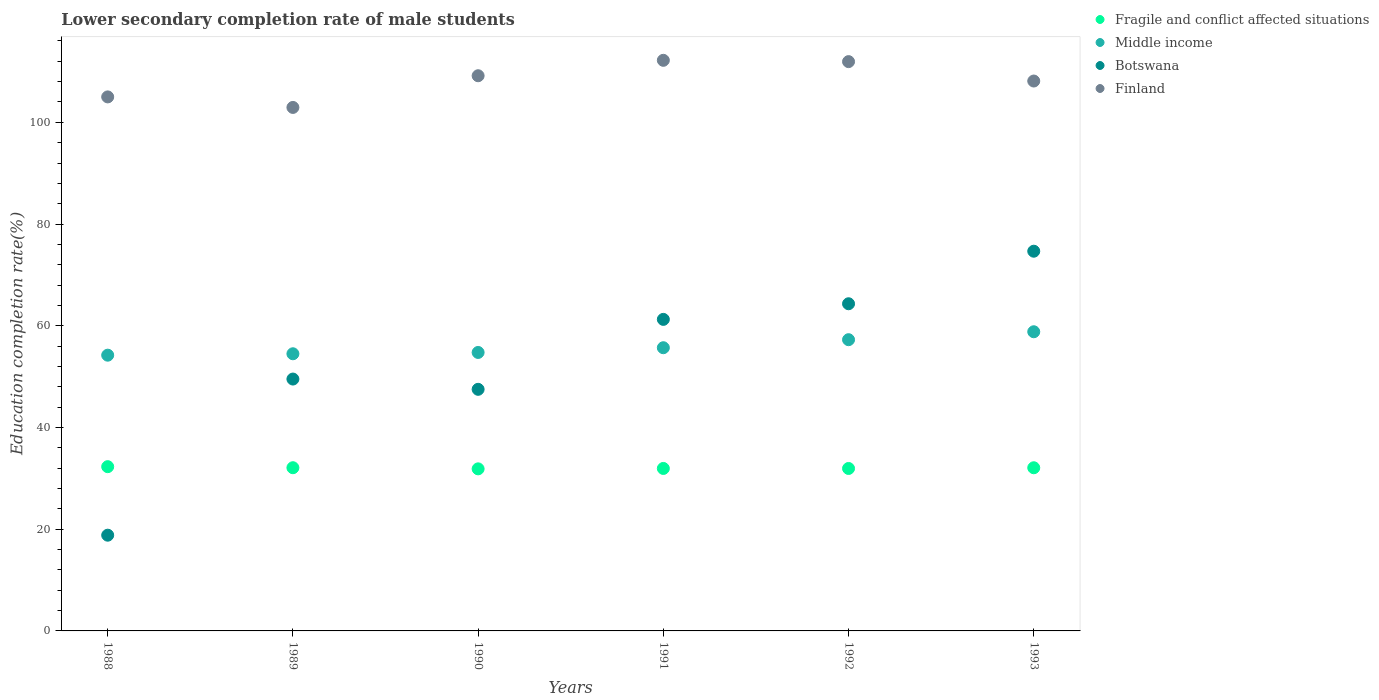How many different coloured dotlines are there?
Offer a very short reply. 4. What is the lower secondary completion rate of male students in Middle income in 1992?
Your answer should be very brief. 57.26. Across all years, what is the maximum lower secondary completion rate of male students in Botswana?
Offer a very short reply. 74.66. Across all years, what is the minimum lower secondary completion rate of male students in Middle income?
Your answer should be very brief. 54.22. In which year was the lower secondary completion rate of male students in Botswana maximum?
Give a very brief answer. 1993. In which year was the lower secondary completion rate of male students in Fragile and conflict affected situations minimum?
Provide a succinct answer. 1990. What is the total lower secondary completion rate of male students in Middle income in the graph?
Provide a short and direct response. 335.22. What is the difference between the lower secondary completion rate of male students in Botswana in 1989 and that in 1991?
Your answer should be compact. -11.73. What is the difference between the lower secondary completion rate of male students in Fragile and conflict affected situations in 1991 and the lower secondary completion rate of male students in Middle income in 1992?
Offer a terse response. -25.31. What is the average lower secondary completion rate of male students in Middle income per year?
Provide a short and direct response. 55.87. In the year 1989, what is the difference between the lower secondary completion rate of male students in Botswana and lower secondary completion rate of male students in Finland?
Make the answer very short. -53.4. What is the ratio of the lower secondary completion rate of male students in Fragile and conflict affected situations in 1991 to that in 1992?
Your answer should be very brief. 1. Is the lower secondary completion rate of male students in Finland in 1991 less than that in 1993?
Ensure brevity in your answer.  No. What is the difference between the highest and the second highest lower secondary completion rate of male students in Middle income?
Keep it short and to the point. 1.56. What is the difference between the highest and the lowest lower secondary completion rate of male students in Botswana?
Your answer should be compact. 55.83. In how many years, is the lower secondary completion rate of male students in Botswana greater than the average lower secondary completion rate of male students in Botswana taken over all years?
Ensure brevity in your answer.  3. Is the sum of the lower secondary completion rate of male students in Finland in 1988 and 1989 greater than the maximum lower secondary completion rate of male students in Fragile and conflict affected situations across all years?
Your answer should be very brief. Yes. Is it the case that in every year, the sum of the lower secondary completion rate of male students in Botswana and lower secondary completion rate of male students in Fragile and conflict affected situations  is greater than the sum of lower secondary completion rate of male students in Finland and lower secondary completion rate of male students in Middle income?
Provide a short and direct response. No. Is it the case that in every year, the sum of the lower secondary completion rate of male students in Fragile and conflict affected situations and lower secondary completion rate of male students in Finland  is greater than the lower secondary completion rate of male students in Botswana?
Offer a terse response. Yes. Does the lower secondary completion rate of male students in Botswana monotonically increase over the years?
Keep it short and to the point. No. Is the lower secondary completion rate of male students in Finland strictly less than the lower secondary completion rate of male students in Fragile and conflict affected situations over the years?
Provide a short and direct response. No. What is the difference between two consecutive major ticks on the Y-axis?
Your answer should be very brief. 20. Are the values on the major ticks of Y-axis written in scientific E-notation?
Your response must be concise. No. Does the graph contain grids?
Keep it short and to the point. No. What is the title of the graph?
Give a very brief answer. Lower secondary completion rate of male students. Does "Uzbekistan" appear as one of the legend labels in the graph?
Make the answer very short. No. What is the label or title of the Y-axis?
Offer a terse response. Education completion rate(%). What is the Education completion rate(%) in Fragile and conflict affected situations in 1988?
Your answer should be compact. 32.29. What is the Education completion rate(%) in Middle income in 1988?
Offer a very short reply. 54.22. What is the Education completion rate(%) in Botswana in 1988?
Your answer should be compact. 18.82. What is the Education completion rate(%) of Finland in 1988?
Your answer should be compact. 105. What is the Education completion rate(%) of Fragile and conflict affected situations in 1989?
Your answer should be compact. 32.09. What is the Education completion rate(%) in Middle income in 1989?
Keep it short and to the point. 54.49. What is the Education completion rate(%) in Botswana in 1989?
Your response must be concise. 49.52. What is the Education completion rate(%) of Finland in 1989?
Ensure brevity in your answer.  102.93. What is the Education completion rate(%) of Fragile and conflict affected situations in 1990?
Your response must be concise. 31.86. What is the Education completion rate(%) of Middle income in 1990?
Ensure brevity in your answer.  54.75. What is the Education completion rate(%) of Botswana in 1990?
Offer a terse response. 47.5. What is the Education completion rate(%) in Finland in 1990?
Your answer should be very brief. 109.16. What is the Education completion rate(%) in Fragile and conflict affected situations in 1991?
Your answer should be very brief. 31.94. What is the Education completion rate(%) in Middle income in 1991?
Your response must be concise. 55.68. What is the Education completion rate(%) in Botswana in 1991?
Provide a short and direct response. 61.25. What is the Education completion rate(%) in Finland in 1991?
Your answer should be compact. 112.19. What is the Education completion rate(%) in Fragile and conflict affected situations in 1992?
Give a very brief answer. 31.94. What is the Education completion rate(%) of Middle income in 1992?
Keep it short and to the point. 57.26. What is the Education completion rate(%) in Botswana in 1992?
Your response must be concise. 64.33. What is the Education completion rate(%) in Finland in 1992?
Keep it short and to the point. 111.93. What is the Education completion rate(%) in Fragile and conflict affected situations in 1993?
Your answer should be very brief. 32.08. What is the Education completion rate(%) of Middle income in 1993?
Give a very brief answer. 58.82. What is the Education completion rate(%) of Botswana in 1993?
Provide a succinct answer. 74.66. What is the Education completion rate(%) in Finland in 1993?
Offer a very short reply. 108.12. Across all years, what is the maximum Education completion rate(%) in Fragile and conflict affected situations?
Ensure brevity in your answer.  32.29. Across all years, what is the maximum Education completion rate(%) in Middle income?
Offer a very short reply. 58.82. Across all years, what is the maximum Education completion rate(%) in Botswana?
Ensure brevity in your answer.  74.66. Across all years, what is the maximum Education completion rate(%) in Finland?
Your answer should be very brief. 112.19. Across all years, what is the minimum Education completion rate(%) in Fragile and conflict affected situations?
Provide a short and direct response. 31.86. Across all years, what is the minimum Education completion rate(%) of Middle income?
Offer a very short reply. 54.22. Across all years, what is the minimum Education completion rate(%) of Botswana?
Provide a short and direct response. 18.82. Across all years, what is the minimum Education completion rate(%) in Finland?
Provide a succinct answer. 102.93. What is the total Education completion rate(%) of Fragile and conflict affected situations in the graph?
Offer a very short reply. 192.21. What is the total Education completion rate(%) of Middle income in the graph?
Provide a short and direct response. 335.22. What is the total Education completion rate(%) of Botswana in the graph?
Offer a very short reply. 316.08. What is the total Education completion rate(%) in Finland in the graph?
Your answer should be very brief. 649.32. What is the difference between the Education completion rate(%) in Fragile and conflict affected situations in 1988 and that in 1989?
Give a very brief answer. 0.21. What is the difference between the Education completion rate(%) in Middle income in 1988 and that in 1989?
Your answer should be very brief. -0.28. What is the difference between the Education completion rate(%) in Botswana in 1988 and that in 1989?
Your response must be concise. -30.7. What is the difference between the Education completion rate(%) of Finland in 1988 and that in 1989?
Provide a succinct answer. 2.07. What is the difference between the Education completion rate(%) of Fragile and conflict affected situations in 1988 and that in 1990?
Offer a terse response. 0.43. What is the difference between the Education completion rate(%) in Middle income in 1988 and that in 1990?
Offer a very short reply. -0.54. What is the difference between the Education completion rate(%) in Botswana in 1988 and that in 1990?
Provide a short and direct response. -28.68. What is the difference between the Education completion rate(%) in Finland in 1988 and that in 1990?
Keep it short and to the point. -4.16. What is the difference between the Education completion rate(%) in Fragile and conflict affected situations in 1988 and that in 1991?
Give a very brief answer. 0.35. What is the difference between the Education completion rate(%) in Middle income in 1988 and that in 1991?
Ensure brevity in your answer.  -1.47. What is the difference between the Education completion rate(%) in Botswana in 1988 and that in 1991?
Provide a short and direct response. -42.43. What is the difference between the Education completion rate(%) in Finland in 1988 and that in 1991?
Make the answer very short. -7.19. What is the difference between the Education completion rate(%) of Fragile and conflict affected situations in 1988 and that in 1992?
Provide a short and direct response. 0.35. What is the difference between the Education completion rate(%) in Middle income in 1988 and that in 1992?
Make the answer very short. -3.04. What is the difference between the Education completion rate(%) in Botswana in 1988 and that in 1992?
Your response must be concise. -45.5. What is the difference between the Education completion rate(%) of Finland in 1988 and that in 1992?
Provide a succinct answer. -6.94. What is the difference between the Education completion rate(%) in Fragile and conflict affected situations in 1988 and that in 1993?
Keep it short and to the point. 0.21. What is the difference between the Education completion rate(%) of Middle income in 1988 and that in 1993?
Provide a succinct answer. -4.6. What is the difference between the Education completion rate(%) in Botswana in 1988 and that in 1993?
Give a very brief answer. -55.83. What is the difference between the Education completion rate(%) in Finland in 1988 and that in 1993?
Provide a short and direct response. -3.12. What is the difference between the Education completion rate(%) in Fragile and conflict affected situations in 1989 and that in 1990?
Make the answer very short. 0.22. What is the difference between the Education completion rate(%) in Middle income in 1989 and that in 1990?
Make the answer very short. -0.26. What is the difference between the Education completion rate(%) in Botswana in 1989 and that in 1990?
Keep it short and to the point. 2.02. What is the difference between the Education completion rate(%) in Finland in 1989 and that in 1990?
Provide a short and direct response. -6.23. What is the difference between the Education completion rate(%) of Fragile and conflict affected situations in 1989 and that in 1991?
Provide a short and direct response. 0.14. What is the difference between the Education completion rate(%) in Middle income in 1989 and that in 1991?
Offer a very short reply. -1.19. What is the difference between the Education completion rate(%) in Botswana in 1989 and that in 1991?
Provide a succinct answer. -11.73. What is the difference between the Education completion rate(%) in Finland in 1989 and that in 1991?
Give a very brief answer. -9.26. What is the difference between the Education completion rate(%) in Fragile and conflict affected situations in 1989 and that in 1992?
Make the answer very short. 0.15. What is the difference between the Education completion rate(%) of Middle income in 1989 and that in 1992?
Make the answer very short. -2.77. What is the difference between the Education completion rate(%) in Botswana in 1989 and that in 1992?
Provide a short and direct response. -14.8. What is the difference between the Education completion rate(%) in Finland in 1989 and that in 1992?
Offer a very short reply. -9.01. What is the difference between the Education completion rate(%) of Fragile and conflict affected situations in 1989 and that in 1993?
Ensure brevity in your answer.  0.01. What is the difference between the Education completion rate(%) in Middle income in 1989 and that in 1993?
Provide a succinct answer. -4.33. What is the difference between the Education completion rate(%) of Botswana in 1989 and that in 1993?
Give a very brief answer. -25.14. What is the difference between the Education completion rate(%) in Finland in 1989 and that in 1993?
Offer a terse response. -5.19. What is the difference between the Education completion rate(%) in Fragile and conflict affected situations in 1990 and that in 1991?
Keep it short and to the point. -0.08. What is the difference between the Education completion rate(%) in Middle income in 1990 and that in 1991?
Your answer should be compact. -0.93. What is the difference between the Education completion rate(%) in Botswana in 1990 and that in 1991?
Offer a very short reply. -13.75. What is the difference between the Education completion rate(%) of Finland in 1990 and that in 1991?
Make the answer very short. -3.03. What is the difference between the Education completion rate(%) in Fragile and conflict affected situations in 1990 and that in 1992?
Make the answer very short. -0.08. What is the difference between the Education completion rate(%) in Middle income in 1990 and that in 1992?
Provide a short and direct response. -2.51. What is the difference between the Education completion rate(%) in Botswana in 1990 and that in 1992?
Offer a very short reply. -16.82. What is the difference between the Education completion rate(%) in Finland in 1990 and that in 1992?
Make the answer very short. -2.77. What is the difference between the Education completion rate(%) of Fragile and conflict affected situations in 1990 and that in 1993?
Your answer should be compact. -0.22. What is the difference between the Education completion rate(%) of Middle income in 1990 and that in 1993?
Your answer should be compact. -4.07. What is the difference between the Education completion rate(%) of Botswana in 1990 and that in 1993?
Your response must be concise. -27.15. What is the difference between the Education completion rate(%) of Finland in 1990 and that in 1993?
Your answer should be very brief. 1.04. What is the difference between the Education completion rate(%) of Fragile and conflict affected situations in 1991 and that in 1992?
Keep it short and to the point. 0. What is the difference between the Education completion rate(%) of Middle income in 1991 and that in 1992?
Give a very brief answer. -1.58. What is the difference between the Education completion rate(%) of Botswana in 1991 and that in 1992?
Offer a very short reply. -3.07. What is the difference between the Education completion rate(%) in Finland in 1991 and that in 1992?
Offer a very short reply. 0.26. What is the difference between the Education completion rate(%) of Fragile and conflict affected situations in 1991 and that in 1993?
Provide a succinct answer. -0.14. What is the difference between the Education completion rate(%) in Middle income in 1991 and that in 1993?
Ensure brevity in your answer.  -3.14. What is the difference between the Education completion rate(%) of Botswana in 1991 and that in 1993?
Give a very brief answer. -13.4. What is the difference between the Education completion rate(%) in Finland in 1991 and that in 1993?
Keep it short and to the point. 4.07. What is the difference between the Education completion rate(%) in Fragile and conflict affected situations in 1992 and that in 1993?
Give a very brief answer. -0.14. What is the difference between the Education completion rate(%) in Middle income in 1992 and that in 1993?
Provide a succinct answer. -1.56. What is the difference between the Education completion rate(%) of Botswana in 1992 and that in 1993?
Make the answer very short. -10.33. What is the difference between the Education completion rate(%) in Finland in 1992 and that in 1993?
Make the answer very short. 3.81. What is the difference between the Education completion rate(%) of Fragile and conflict affected situations in 1988 and the Education completion rate(%) of Middle income in 1989?
Your answer should be compact. -22.2. What is the difference between the Education completion rate(%) of Fragile and conflict affected situations in 1988 and the Education completion rate(%) of Botswana in 1989?
Your response must be concise. -17.23. What is the difference between the Education completion rate(%) in Fragile and conflict affected situations in 1988 and the Education completion rate(%) in Finland in 1989?
Keep it short and to the point. -70.63. What is the difference between the Education completion rate(%) in Middle income in 1988 and the Education completion rate(%) in Botswana in 1989?
Keep it short and to the point. 4.69. What is the difference between the Education completion rate(%) in Middle income in 1988 and the Education completion rate(%) in Finland in 1989?
Offer a terse response. -48.71. What is the difference between the Education completion rate(%) in Botswana in 1988 and the Education completion rate(%) in Finland in 1989?
Offer a terse response. -84.1. What is the difference between the Education completion rate(%) of Fragile and conflict affected situations in 1988 and the Education completion rate(%) of Middle income in 1990?
Give a very brief answer. -22.46. What is the difference between the Education completion rate(%) in Fragile and conflict affected situations in 1988 and the Education completion rate(%) in Botswana in 1990?
Provide a short and direct response. -15.21. What is the difference between the Education completion rate(%) of Fragile and conflict affected situations in 1988 and the Education completion rate(%) of Finland in 1990?
Give a very brief answer. -76.86. What is the difference between the Education completion rate(%) of Middle income in 1988 and the Education completion rate(%) of Botswana in 1990?
Your answer should be compact. 6.71. What is the difference between the Education completion rate(%) in Middle income in 1988 and the Education completion rate(%) in Finland in 1990?
Provide a succinct answer. -54.94. What is the difference between the Education completion rate(%) of Botswana in 1988 and the Education completion rate(%) of Finland in 1990?
Offer a very short reply. -90.33. What is the difference between the Education completion rate(%) in Fragile and conflict affected situations in 1988 and the Education completion rate(%) in Middle income in 1991?
Make the answer very short. -23.39. What is the difference between the Education completion rate(%) in Fragile and conflict affected situations in 1988 and the Education completion rate(%) in Botswana in 1991?
Make the answer very short. -28.96. What is the difference between the Education completion rate(%) in Fragile and conflict affected situations in 1988 and the Education completion rate(%) in Finland in 1991?
Offer a terse response. -79.9. What is the difference between the Education completion rate(%) in Middle income in 1988 and the Education completion rate(%) in Botswana in 1991?
Provide a succinct answer. -7.04. What is the difference between the Education completion rate(%) in Middle income in 1988 and the Education completion rate(%) in Finland in 1991?
Your answer should be compact. -57.97. What is the difference between the Education completion rate(%) in Botswana in 1988 and the Education completion rate(%) in Finland in 1991?
Provide a succinct answer. -93.37. What is the difference between the Education completion rate(%) in Fragile and conflict affected situations in 1988 and the Education completion rate(%) in Middle income in 1992?
Offer a terse response. -24.96. What is the difference between the Education completion rate(%) of Fragile and conflict affected situations in 1988 and the Education completion rate(%) of Botswana in 1992?
Offer a very short reply. -32.03. What is the difference between the Education completion rate(%) of Fragile and conflict affected situations in 1988 and the Education completion rate(%) of Finland in 1992?
Keep it short and to the point. -79.64. What is the difference between the Education completion rate(%) of Middle income in 1988 and the Education completion rate(%) of Botswana in 1992?
Your response must be concise. -10.11. What is the difference between the Education completion rate(%) in Middle income in 1988 and the Education completion rate(%) in Finland in 1992?
Your answer should be very brief. -57.72. What is the difference between the Education completion rate(%) of Botswana in 1988 and the Education completion rate(%) of Finland in 1992?
Keep it short and to the point. -93.11. What is the difference between the Education completion rate(%) of Fragile and conflict affected situations in 1988 and the Education completion rate(%) of Middle income in 1993?
Keep it short and to the point. -26.53. What is the difference between the Education completion rate(%) in Fragile and conflict affected situations in 1988 and the Education completion rate(%) in Botswana in 1993?
Provide a short and direct response. -42.36. What is the difference between the Education completion rate(%) of Fragile and conflict affected situations in 1988 and the Education completion rate(%) of Finland in 1993?
Offer a very short reply. -75.82. What is the difference between the Education completion rate(%) in Middle income in 1988 and the Education completion rate(%) in Botswana in 1993?
Your response must be concise. -20.44. What is the difference between the Education completion rate(%) in Middle income in 1988 and the Education completion rate(%) in Finland in 1993?
Give a very brief answer. -53.9. What is the difference between the Education completion rate(%) of Botswana in 1988 and the Education completion rate(%) of Finland in 1993?
Your answer should be very brief. -89.29. What is the difference between the Education completion rate(%) in Fragile and conflict affected situations in 1989 and the Education completion rate(%) in Middle income in 1990?
Your response must be concise. -22.66. What is the difference between the Education completion rate(%) of Fragile and conflict affected situations in 1989 and the Education completion rate(%) of Botswana in 1990?
Your answer should be very brief. -15.41. What is the difference between the Education completion rate(%) of Fragile and conflict affected situations in 1989 and the Education completion rate(%) of Finland in 1990?
Offer a very short reply. -77.07. What is the difference between the Education completion rate(%) in Middle income in 1989 and the Education completion rate(%) in Botswana in 1990?
Provide a short and direct response. 6.99. What is the difference between the Education completion rate(%) in Middle income in 1989 and the Education completion rate(%) in Finland in 1990?
Provide a short and direct response. -54.66. What is the difference between the Education completion rate(%) of Botswana in 1989 and the Education completion rate(%) of Finland in 1990?
Your answer should be compact. -59.64. What is the difference between the Education completion rate(%) in Fragile and conflict affected situations in 1989 and the Education completion rate(%) in Middle income in 1991?
Your answer should be compact. -23.59. What is the difference between the Education completion rate(%) of Fragile and conflict affected situations in 1989 and the Education completion rate(%) of Botswana in 1991?
Make the answer very short. -29.16. What is the difference between the Education completion rate(%) in Fragile and conflict affected situations in 1989 and the Education completion rate(%) in Finland in 1991?
Give a very brief answer. -80.1. What is the difference between the Education completion rate(%) in Middle income in 1989 and the Education completion rate(%) in Botswana in 1991?
Ensure brevity in your answer.  -6.76. What is the difference between the Education completion rate(%) of Middle income in 1989 and the Education completion rate(%) of Finland in 1991?
Your answer should be compact. -57.7. What is the difference between the Education completion rate(%) of Botswana in 1989 and the Education completion rate(%) of Finland in 1991?
Your answer should be very brief. -62.67. What is the difference between the Education completion rate(%) in Fragile and conflict affected situations in 1989 and the Education completion rate(%) in Middle income in 1992?
Ensure brevity in your answer.  -25.17. What is the difference between the Education completion rate(%) in Fragile and conflict affected situations in 1989 and the Education completion rate(%) in Botswana in 1992?
Make the answer very short. -32.24. What is the difference between the Education completion rate(%) of Fragile and conflict affected situations in 1989 and the Education completion rate(%) of Finland in 1992?
Make the answer very short. -79.84. What is the difference between the Education completion rate(%) in Middle income in 1989 and the Education completion rate(%) in Botswana in 1992?
Your response must be concise. -9.83. What is the difference between the Education completion rate(%) in Middle income in 1989 and the Education completion rate(%) in Finland in 1992?
Make the answer very short. -57.44. What is the difference between the Education completion rate(%) in Botswana in 1989 and the Education completion rate(%) in Finland in 1992?
Make the answer very short. -62.41. What is the difference between the Education completion rate(%) of Fragile and conflict affected situations in 1989 and the Education completion rate(%) of Middle income in 1993?
Provide a short and direct response. -26.73. What is the difference between the Education completion rate(%) of Fragile and conflict affected situations in 1989 and the Education completion rate(%) of Botswana in 1993?
Your answer should be compact. -42.57. What is the difference between the Education completion rate(%) of Fragile and conflict affected situations in 1989 and the Education completion rate(%) of Finland in 1993?
Your answer should be compact. -76.03. What is the difference between the Education completion rate(%) of Middle income in 1989 and the Education completion rate(%) of Botswana in 1993?
Ensure brevity in your answer.  -20.16. What is the difference between the Education completion rate(%) of Middle income in 1989 and the Education completion rate(%) of Finland in 1993?
Provide a short and direct response. -53.62. What is the difference between the Education completion rate(%) in Botswana in 1989 and the Education completion rate(%) in Finland in 1993?
Your response must be concise. -58.6. What is the difference between the Education completion rate(%) of Fragile and conflict affected situations in 1990 and the Education completion rate(%) of Middle income in 1991?
Your answer should be compact. -23.82. What is the difference between the Education completion rate(%) of Fragile and conflict affected situations in 1990 and the Education completion rate(%) of Botswana in 1991?
Your answer should be very brief. -29.39. What is the difference between the Education completion rate(%) of Fragile and conflict affected situations in 1990 and the Education completion rate(%) of Finland in 1991?
Give a very brief answer. -80.32. What is the difference between the Education completion rate(%) of Middle income in 1990 and the Education completion rate(%) of Botswana in 1991?
Your answer should be very brief. -6.5. What is the difference between the Education completion rate(%) in Middle income in 1990 and the Education completion rate(%) in Finland in 1991?
Provide a short and direct response. -57.44. What is the difference between the Education completion rate(%) of Botswana in 1990 and the Education completion rate(%) of Finland in 1991?
Ensure brevity in your answer.  -64.69. What is the difference between the Education completion rate(%) of Fragile and conflict affected situations in 1990 and the Education completion rate(%) of Middle income in 1992?
Your response must be concise. -25.39. What is the difference between the Education completion rate(%) of Fragile and conflict affected situations in 1990 and the Education completion rate(%) of Botswana in 1992?
Your response must be concise. -32.46. What is the difference between the Education completion rate(%) of Fragile and conflict affected situations in 1990 and the Education completion rate(%) of Finland in 1992?
Make the answer very short. -80.07. What is the difference between the Education completion rate(%) of Middle income in 1990 and the Education completion rate(%) of Botswana in 1992?
Your response must be concise. -9.58. What is the difference between the Education completion rate(%) in Middle income in 1990 and the Education completion rate(%) in Finland in 1992?
Make the answer very short. -57.18. What is the difference between the Education completion rate(%) in Botswana in 1990 and the Education completion rate(%) in Finland in 1992?
Keep it short and to the point. -64.43. What is the difference between the Education completion rate(%) in Fragile and conflict affected situations in 1990 and the Education completion rate(%) in Middle income in 1993?
Offer a terse response. -26.96. What is the difference between the Education completion rate(%) of Fragile and conflict affected situations in 1990 and the Education completion rate(%) of Botswana in 1993?
Offer a terse response. -42.79. What is the difference between the Education completion rate(%) in Fragile and conflict affected situations in 1990 and the Education completion rate(%) in Finland in 1993?
Ensure brevity in your answer.  -76.25. What is the difference between the Education completion rate(%) in Middle income in 1990 and the Education completion rate(%) in Botswana in 1993?
Keep it short and to the point. -19.91. What is the difference between the Education completion rate(%) in Middle income in 1990 and the Education completion rate(%) in Finland in 1993?
Provide a short and direct response. -53.37. What is the difference between the Education completion rate(%) of Botswana in 1990 and the Education completion rate(%) of Finland in 1993?
Provide a succinct answer. -60.62. What is the difference between the Education completion rate(%) of Fragile and conflict affected situations in 1991 and the Education completion rate(%) of Middle income in 1992?
Offer a very short reply. -25.31. What is the difference between the Education completion rate(%) in Fragile and conflict affected situations in 1991 and the Education completion rate(%) in Botswana in 1992?
Provide a short and direct response. -32.38. What is the difference between the Education completion rate(%) of Fragile and conflict affected situations in 1991 and the Education completion rate(%) of Finland in 1992?
Give a very brief answer. -79.99. What is the difference between the Education completion rate(%) of Middle income in 1991 and the Education completion rate(%) of Botswana in 1992?
Your answer should be compact. -8.64. What is the difference between the Education completion rate(%) of Middle income in 1991 and the Education completion rate(%) of Finland in 1992?
Keep it short and to the point. -56.25. What is the difference between the Education completion rate(%) of Botswana in 1991 and the Education completion rate(%) of Finland in 1992?
Provide a short and direct response. -50.68. What is the difference between the Education completion rate(%) in Fragile and conflict affected situations in 1991 and the Education completion rate(%) in Middle income in 1993?
Make the answer very short. -26.88. What is the difference between the Education completion rate(%) in Fragile and conflict affected situations in 1991 and the Education completion rate(%) in Botswana in 1993?
Offer a very short reply. -42.71. What is the difference between the Education completion rate(%) in Fragile and conflict affected situations in 1991 and the Education completion rate(%) in Finland in 1993?
Your answer should be compact. -76.17. What is the difference between the Education completion rate(%) of Middle income in 1991 and the Education completion rate(%) of Botswana in 1993?
Your response must be concise. -18.97. What is the difference between the Education completion rate(%) in Middle income in 1991 and the Education completion rate(%) in Finland in 1993?
Your response must be concise. -52.44. What is the difference between the Education completion rate(%) in Botswana in 1991 and the Education completion rate(%) in Finland in 1993?
Your answer should be compact. -46.86. What is the difference between the Education completion rate(%) of Fragile and conflict affected situations in 1992 and the Education completion rate(%) of Middle income in 1993?
Make the answer very short. -26.88. What is the difference between the Education completion rate(%) of Fragile and conflict affected situations in 1992 and the Education completion rate(%) of Botswana in 1993?
Provide a succinct answer. -42.72. What is the difference between the Education completion rate(%) in Fragile and conflict affected situations in 1992 and the Education completion rate(%) in Finland in 1993?
Offer a very short reply. -76.18. What is the difference between the Education completion rate(%) in Middle income in 1992 and the Education completion rate(%) in Botswana in 1993?
Your answer should be compact. -17.4. What is the difference between the Education completion rate(%) of Middle income in 1992 and the Education completion rate(%) of Finland in 1993?
Your response must be concise. -50.86. What is the difference between the Education completion rate(%) of Botswana in 1992 and the Education completion rate(%) of Finland in 1993?
Your answer should be very brief. -43.79. What is the average Education completion rate(%) in Fragile and conflict affected situations per year?
Provide a short and direct response. 32.04. What is the average Education completion rate(%) of Middle income per year?
Your answer should be compact. 55.87. What is the average Education completion rate(%) in Botswana per year?
Offer a very short reply. 52.68. What is the average Education completion rate(%) of Finland per year?
Your answer should be compact. 108.22. In the year 1988, what is the difference between the Education completion rate(%) in Fragile and conflict affected situations and Education completion rate(%) in Middle income?
Give a very brief answer. -21.92. In the year 1988, what is the difference between the Education completion rate(%) in Fragile and conflict affected situations and Education completion rate(%) in Botswana?
Your answer should be very brief. 13.47. In the year 1988, what is the difference between the Education completion rate(%) of Fragile and conflict affected situations and Education completion rate(%) of Finland?
Keep it short and to the point. -72.7. In the year 1988, what is the difference between the Education completion rate(%) in Middle income and Education completion rate(%) in Botswana?
Your response must be concise. 35.39. In the year 1988, what is the difference between the Education completion rate(%) in Middle income and Education completion rate(%) in Finland?
Give a very brief answer. -50.78. In the year 1988, what is the difference between the Education completion rate(%) in Botswana and Education completion rate(%) in Finland?
Your response must be concise. -86.17. In the year 1989, what is the difference between the Education completion rate(%) in Fragile and conflict affected situations and Education completion rate(%) in Middle income?
Ensure brevity in your answer.  -22.4. In the year 1989, what is the difference between the Education completion rate(%) in Fragile and conflict affected situations and Education completion rate(%) in Botswana?
Your answer should be very brief. -17.43. In the year 1989, what is the difference between the Education completion rate(%) in Fragile and conflict affected situations and Education completion rate(%) in Finland?
Give a very brief answer. -70.84. In the year 1989, what is the difference between the Education completion rate(%) of Middle income and Education completion rate(%) of Botswana?
Provide a short and direct response. 4.97. In the year 1989, what is the difference between the Education completion rate(%) of Middle income and Education completion rate(%) of Finland?
Offer a terse response. -48.43. In the year 1989, what is the difference between the Education completion rate(%) in Botswana and Education completion rate(%) in Finland?
Ensure brevity in your answer.  -53.4. In the year 1990, what is the difference between the Education completion rate(%) of Fragile and conflict affected situations and Education completion rate(%) of Middle income?
Your answer should be compact. -22.89. In the year 1990, what is the difference between the Education completion rate(%) in Fragile and conflict affected situations and Education completion rate(%) in Botswana?
Your answer should be compact. -15.64. In the year 1990, what is the difference between the Education completion rate(%) in Fragile and conflict affected situations and Education completion rate(%) in Finland?
Provide a short and direct response. -77.29. In the year 1990, what is the difference between the Education completion rate(%) in Middle income and Education completion rate(%) in Botswana?
Provide a short and direct response. 7.25. In the year 1990, what is the difference between the Education completion rate(%) of Middle income and Education completion rate(%) of Finland?
Ensure brevity in your answer.  -54.41. In the year 1990, what is the difference between the Education completion rate(%) in Botswana and Education completion rate(%) in Finland?
Provide a succinct answer. -61.66. In the year 1991, what is the difference between the Education completion rate(%) of Fragile and conflict affected situations and Education completion rate(%) of Middle income?
Ensure brevity in your answer.  -23.74. In the year 1991, what is the difference between the Education completion rate(%) of Fragile and conflict affected situations and Education completion rate(%) of Botswana?
Keep it short and to the point. -29.31. In the year 1991, what is the difference between the Education completion rate(%) of Fragile and conflict affected situations and Education completion rate(%) of Finland?
Your answer should be compact. -80.24. In the year 1991, what is the difference between the Education completion rate(%) in Middle income and Education completion rate(%) in Botswana?
Your response must be concise. -5.57. In the year 1991, what is the difference between the Education completion rate(%) in Middle income and Education completion rate(%) in Finland?
Provide a succinct answer. -56.51. In the year 1991, what is the difference between the Education completion rate(%) in Botswana and Education completion rate(%) in Finland?
Ensure brevity in your answer.  -50.94. In the year 1992, what is the difference between the Education completion rate(%) of Fragile and conflict affected situations and Education completion rate(%) of Middle income?
Your response must be concise. -25.32. In the year 1992, what is the difference between the Education completion rate(%) of Fragile and conflict affected situations and Education completion rate(%) of Botswana?
Your answer should be compact. -32.39. In the year 1992, what is the difference between the Education completion rate(%) in Fragile and conflict affected situations and Education completion rate(%) in Finland?
Your answer should be compact. -79.99. In the year 1992, what is the difference between the Education completion rate(%) of Middle income and Education completion rate(%) of Botswana?
Offer a very short reply. -7.07. In the year 1992, what is the difference between the Education completion rate(%) of Middle income and Education completion rate(%) of Finland?
Your response must be concise. -54.67. In the year 1992, what is the difference between the Education completion rate(%) of Botswana and Education completion rate(%) of Finland?
Your answer should be compact. -47.61. In the year 1993, what is the difference between the Education completion rate(%) of Fragile and conflict affected situations and Education completion rate(%) of Middle income?
Give a very brief answer. -26.74. In the year 1993, what is the difference between the Education completion rate(%) of Fragile and conflict affected situations and Education completion rate(%) of Botswana?
Your answer should be compact. -42.58. In the year 1993, what is the difference between the Education completion rate(%) of Fragile and conflict affected situations and Education completion rate(%) of Finland?
Your answer should be compact. -76.04. In the year 1993, what is the difference between the Education completion rate(%) of Middle income and Education completion rate(%) of Botswana?
Offer a very short reply. -15.84. In the year 1993, what is the difference between the Education completion rate(%) in Middle income and Education completion rate(%) in Finland?
Give a very brief answer. -49.3. In the year 1993, what is the difference between the Education completion rate(%) of Botswana and Education completion rate(%) of Finland?
Ensure brevity in your answer.  -33.46. What is the ratio of the Education completion rate(%) of Fragile and conflict affected situations in 1988 to that in 1989?
Give a very brief answer. 1.01. What is the ratio of the Education completion rate(%) in Botswana in 1988 to that in 1989?
Your answer should be very brief. 0.38. What is the ratio of the Education completion rate(%) of Finland in 1988 to that in 1989?
Your answer should be very brief. 1.02. What is the ratio of the Education completion rate(%) of Fragile and conflict affected situations in 1988 to that in 1990?
Your answer should be very brief. 1.01. What is the ratio of the Education completion rate(%) in Middle income in 1988 to that in 1990?
Your answer should be very brief. 0.99. What is the ratio of the Education completion rate(%) of Botswana in 1988 to that in 1990?
Ensure brevity in your answer.  0.4. What is the ratio of the Education completion rate(%) of Finland in 1988 to that in 1990?
Your response must be concise. 0.96. What is the ratio of the Education completion rate(%) of Fragile and conflict affected situations in 1988 to that in 1991?
Your response must be concise. 1.01. What is the ratio of the Education completion rate(%) in Middle income in 1988 to that in 1991?
Your answer should be compact. 0.97. What is the ratio of the Education completion rate(%) of Botswana in 1988 to that in 1991?
Your answer should be compact. 0.31. What is the ratio of the Education completion rate(%) in Finland in 1988 to that in 1991?
Provide a succinct answer. 0.94. What is the ratio of the Education completion rate(%) of Fragile and conflict affected situations in 1988 to that in 1992?
Your response must be concise. 1.01. What is the ratio of the Education completion rate(%) in Middle income in 1988 to that in 1992?
Give a very brief answer. 0.95. What is the ratio of the Education completion rate(%) of Botswana in 1988 to that in 1992?
Your answer should be compact. 0.29. What is the ratio of the Education completion rate(%) of Finland in 1988 to that in 1992?
Provide a short and direct response. 0.94. What is the ratio of the Education completion rate(%) in Middle income in 1988 to that in 1993?
Keep it short and to the point. 0.92. What is the ratio of the Education completion rate(%) in Botswana in 1988 to that in 1993?
Offer a terse response. 0.25. What is the ratio of the Education completion rate(%) in Finland in 1988 to that in 1993?
Make the answer very short. 0.97. What is the ratio of the Education completion rate(%) in Middle income in 1989 to that in 1990?
Provide a succinct answer. 1. What is the ratio of the Education completion rate(%) in Botswana in 1989 to that in 1990?
Give a very brief answer. 1.04. What is the ratio of the Education completion rate(%) of Finland in 1989 to that in 1990?
Your response must be concise. 0.94. What is the ratio of the Education completion rate(%) of Fragile and conflict affected situations in 1989 to that in 1991?
Your answer should be compact. 1. What is the ratio of the Education completion rate(%) in Middle income in 1989 to that in 1991?
Make the answer very short. 0.98. What is the ratio of the Education completion rate(%) of Botswana in 1989 to that in 1991?
Provide a short and direct response. 0.81. What is the ratio of the Education completion rate(%) of Finland in 1989 to that in 1991?
Give a very brief answer. 0.92. What is the ratio of the Education completion rate(%) of Middle income in 1989 to that in 1992?
Give a very brief answer. 0.95. What is the ratio of the Education completion rate(%) of Botswana in 1989 to that in 1992?
Keep it short and to the point. 0.77. What is the ratio of the Education completion rate(%) of Finland in 1989 to that in 1992?
Keep it short and to the point. 0.92. What is the ratio of the Education completion rate(%) of Middle income in 1989 to that in 1993?
Your answer should be compact. 0.93. What is the ratio of the Education completion rate(%) in Botswana in 1989 to that in 1993?
Make the answer very short. 0.66. What is the ratio of the Education completion rate(%) in Finland in 1989 to that in 1993?
Provide a succinct answer. 0.95. What is the ratio of the Education completion rate(%) of Middle income in 1990 to that in 1991?
Offer a terse response. 0.98. What is the ratio of the Education completion rate(%) of Botswana in 1990 to that in 1991?
Your answer should be compact. 0.78. What is the ratio of the Education completion rate(%) in Middle income in 1990 to that in 1992?
Provide a succinct answer. 0.96. What is the ratio of the Education completion rate(%) in Botswana in 1990 to that in 1992?
Keep it short and to the point. 0.74. What is the ratio of the Education completion rate(%) in Finland in 1990 to that in 1992?
Your response must be concise. 0.98. What is the ratio of the Education completion rate(%) of Middle income in 1990 to that in 1993?
Give a very brief answer. 0.93. What is the ratio of the Education completion rate(%) of Botswana in 1990 to that in 1993?
Your answer should be compact. 0.64. What is the ratio of the Education completion rate(%) of Finland in 1990 to that in 1993?
Provide a succinct answer. 1.01. What is the ratio of the Education completion rate(%) of Fragile and conflict affected situations in 1991 to that in 1992?
Your answer should be very brief. 1. What is the ratio of the Education completion rate(%) in Middle income in 1991 to that in 1992?
Offer a terse response. 0.97. What is the ratio of the Education completion rate(%) in Botswana in 1991 to that in 1992?
Provide a short and direct response. 0.95. What is the ratio of the Education completion rate(%) in Finland in 1991 to that in 1992?
Offer a very short reply. 1. What is the ratio of the Education completion rate(%) in Middle income in 1991 to that in 1993?
Provide a short and direct response. 0.95. What is the ratio of the Education completion rate(%) in Botswana in 1991 to that in 1993?
Keep it short and to the point. 0.82. What is the ratio of the Education completion rate(%) of Finland in 1991 to that in 1993?
Offer a terse response. 1.04. What is the ratio of the Education completion rate(%) in Fragile and conflict affected situations in 1992 to that in 1993?
Your response must be concise. 1. What is the ratio of the Education completion rate(%) of Middle income in 1992 to that in 1993?
Give a very brief answer. 0.97. What is the ratio of the Education completion rate(%) of Botswana in 1992 to that in 1993?
Offer a terse response. 0.86. What is the ratio of the Education completion rate(%) of Finland in 1992 to that in 1993?
Ensure brevity in your answer.  1.04. What is the difference between the highest and the second highest Education completion rate(%) of Fragile and conflict affected situations?
Provide a succinct answer. 0.21. What is the difference between the highest and the second highest Education completion rate(%) in Middle income?
Offer a terse response. 1.56. What is the difference between the highest and the second highest Education completion rate(%) in Botswana?
Offer a terse response. 10.33. What is the difference between the highest and the second highest Education completion rate(%) in Finland?
Provide a short and direct response. 0.26. What is the difference between the highest and the lowest Education completion rate(%) in Fragile and conflict affected situations?
Offer a very short reply. 0.43. What is the difference between the highest and the lowest Education completion rate(%) in Middle income?
Give a very brief answer. 4.6. What is the difference between the highest and the lowest Education completion rate(%) in Botswana?
Ensure brevity in your answer.  55.83. What is the difference between the highest and the lowest Education completion rate(%) of Finland?
Your answer should be very brief. 9.26. 